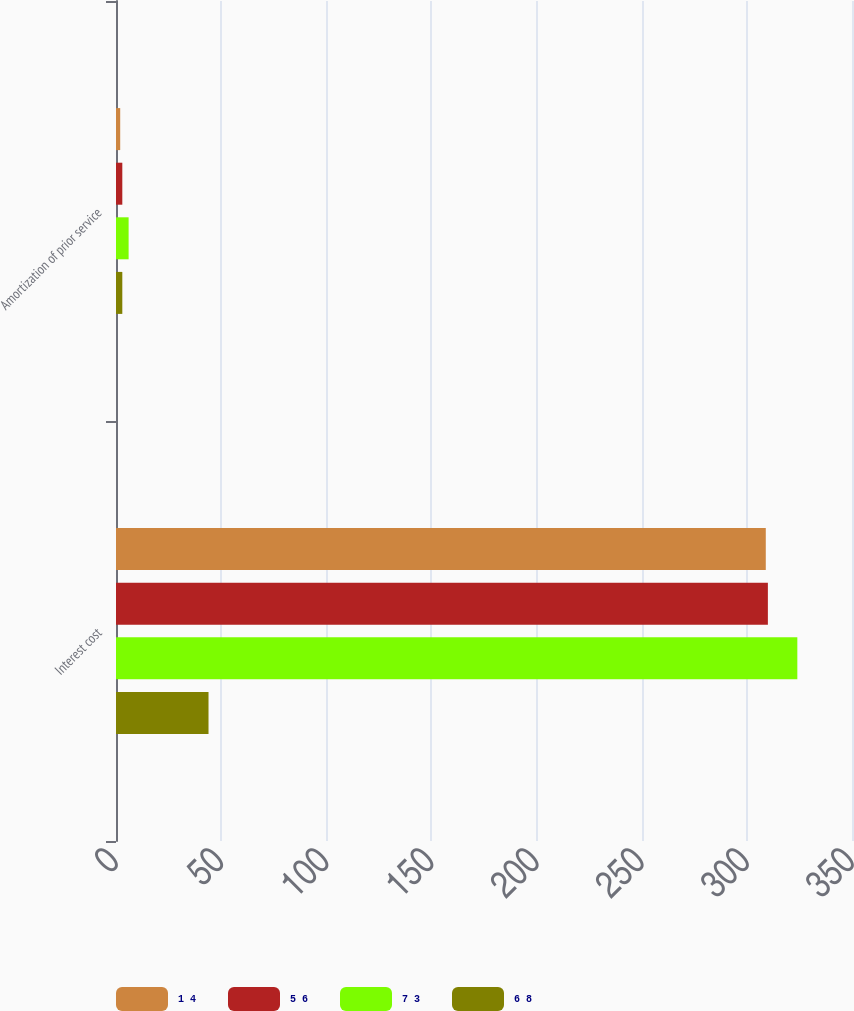<chart> <loc_0><loc_0><loc_500><loc_500><stacked_bar_chart><ecel><fcel>Interest cost<fcel>Amortization of prior service<nl><fcel>1 4<fcel>309<fcel>2<nl><fcel>5 6<fcel>310<fcel>3<nl><fcel>7 3<fcel>324<fcel>6<nl><fcel>6 8<fcel>44<fcel>3<nl></chart> 